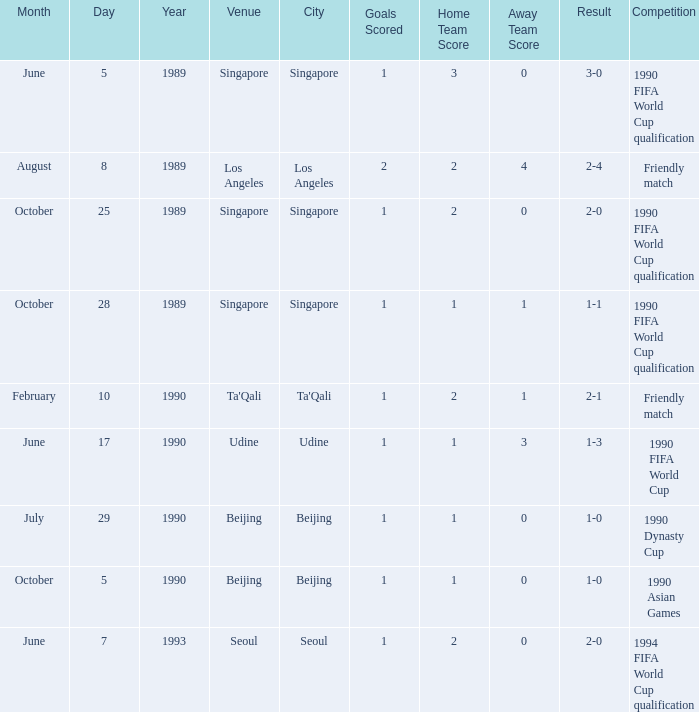What is the outcome of the contest on october 5, 1990? 1 goal. 